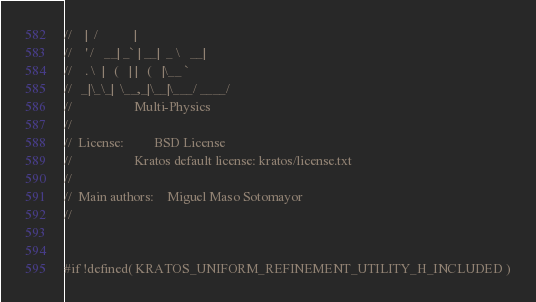<code> <loc_0><loc_0><loc_500><loc_500><_C_>//    |  /           |
//    ' /   __| _` | __|  _ \   __|
//    . \  |   (   | |   (   |\__ `
//   _|\_\_|  \__,_|\__|\___/ ____/
//                   Multi-Physics
//
//  License:		 BSD License
//					 Kratos default license: kratos/license.txt
//
//  Main authors:    Miguel Maso Sotomayor
//


#if !defined( KRATOS_UNIFORM_REFINEMENT_UTILITY_H_INCLUDED )</code> 